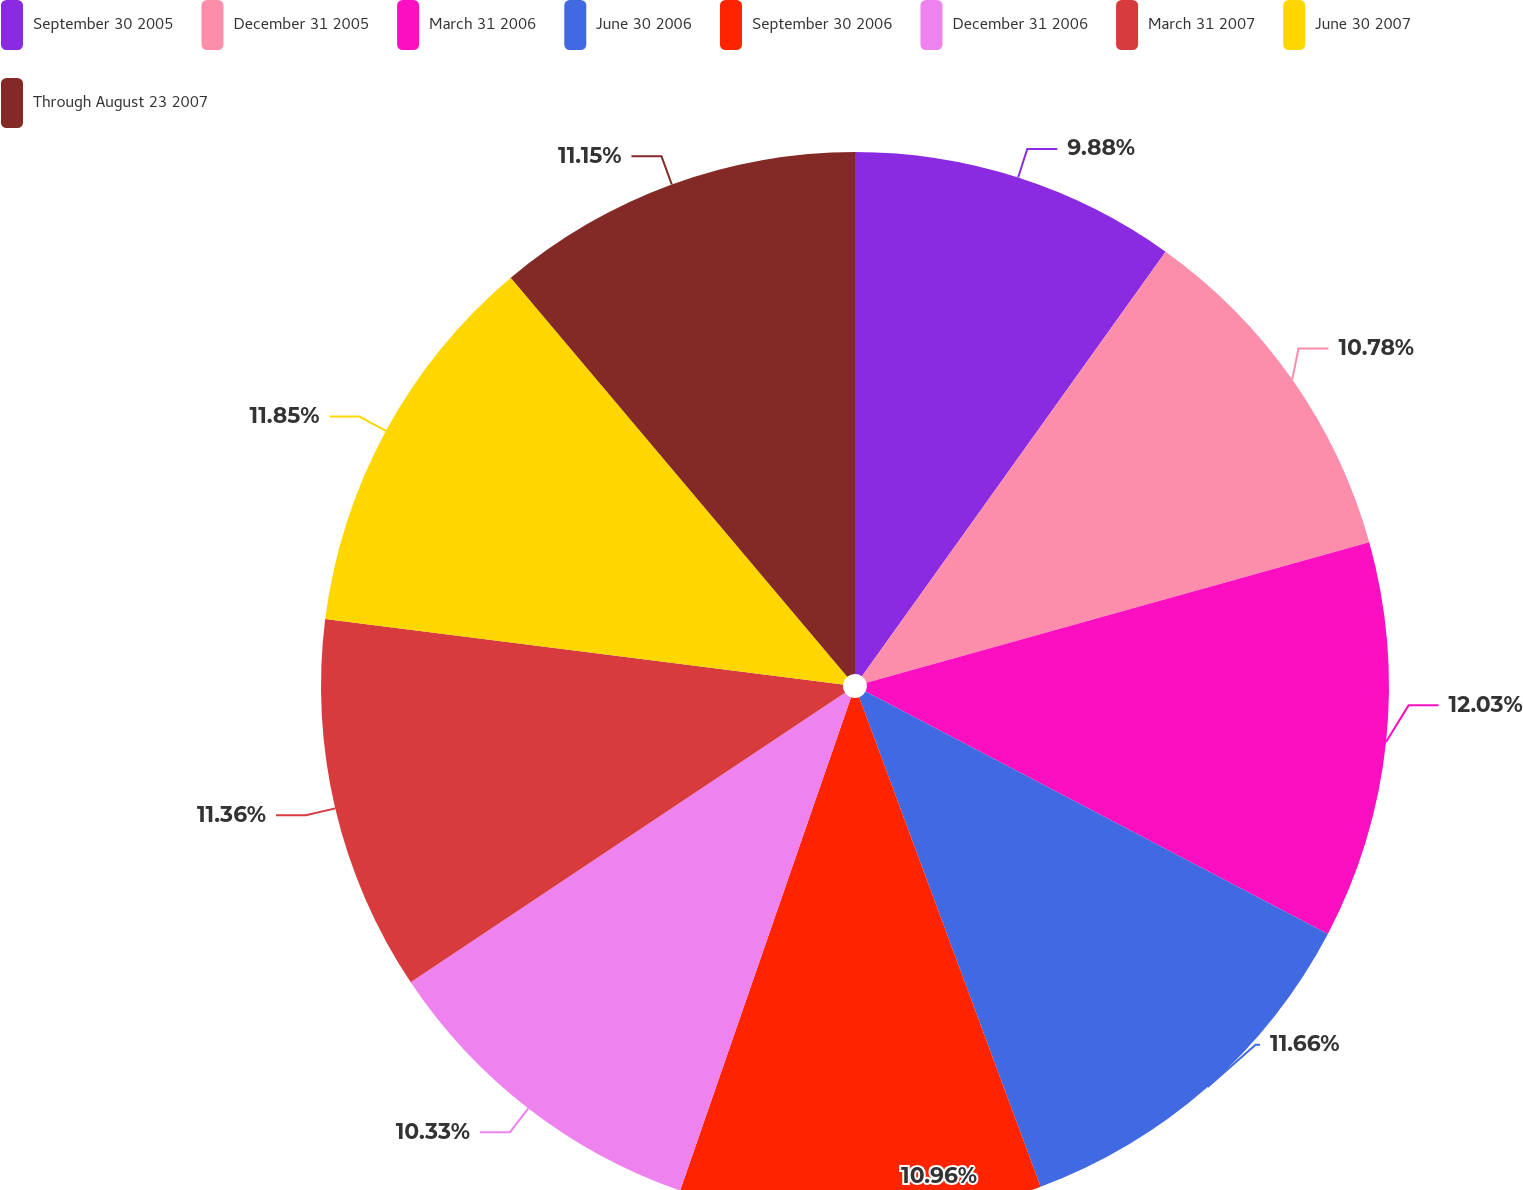<chart> <loc_0><loc_0><loc_500><loc_500><pie_chart><fcel>September 30 2005<fcel>December 31 2005<fcel>March 31 2006<fcel>June 30 2006<fcel>September 30 2006<fcel>December 31 2006<fcel>March 31 2007<fcel>June 30 2007<fcel>Through August 23 2007<nl><fcel>9.88%<fcel>10.78%<fcel>12.03%<fcel>11.66%<fcel>10.96%<fcel>10.33%<fcel>11.36%<fcel>11.85%<fcel>11.15%<nl></chart> 